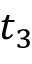Convert formula to latex. <formula><loc_0><loc_0><loc_500><loc_500>t _ { 3 }</formula> 